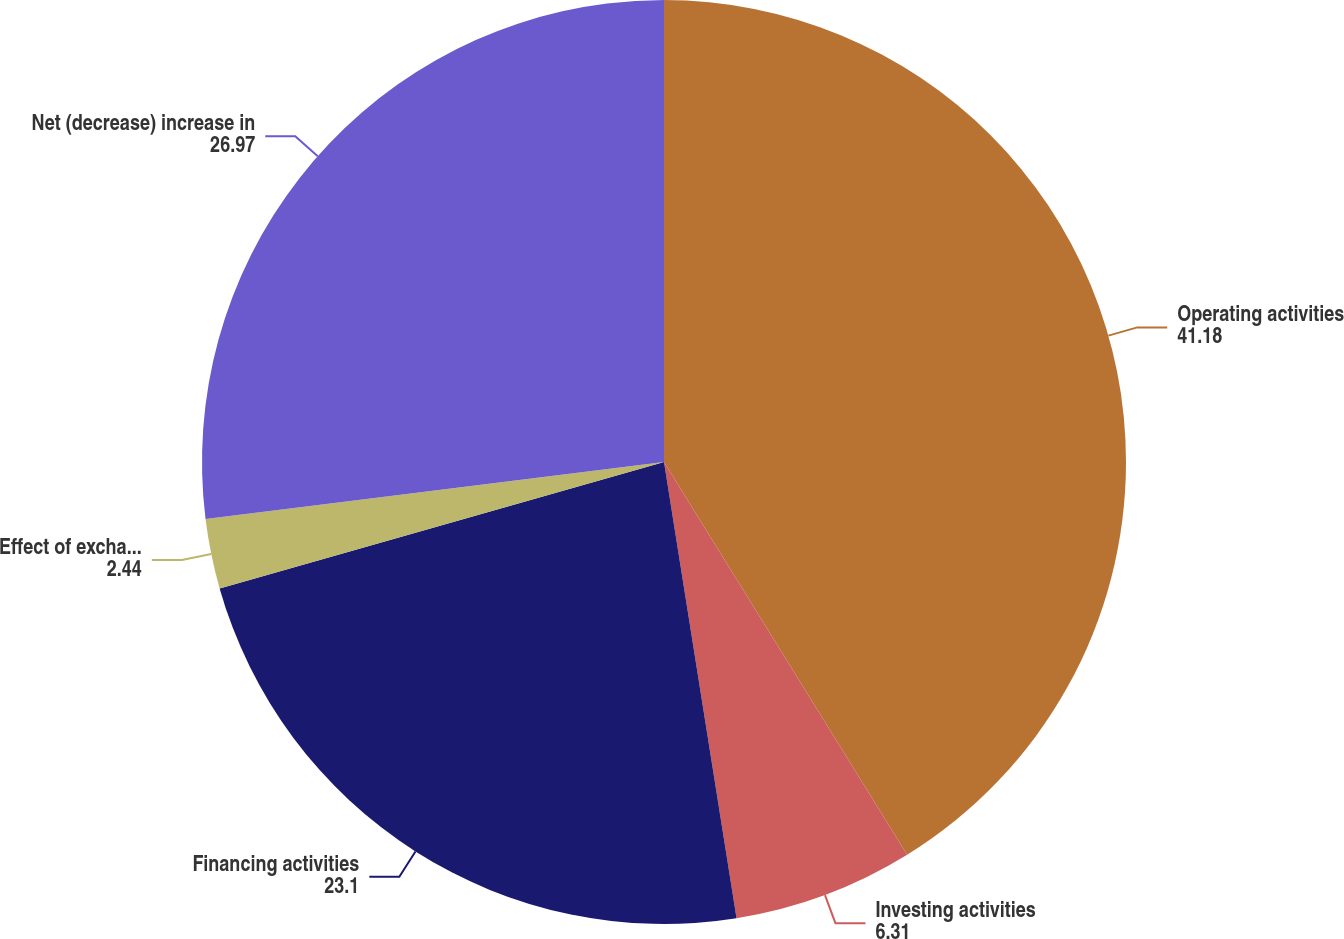<chart> <loc_0><loc_0><loc_500><loc_500><pie_chart><fcel>Operating activities<fcel>Investing activities<fcel>Financing activities<fcel>Effect of exchange rates on<fcel>Net (decrease) increase in<nl><fcel>41.18%<fcel>6.31%<fcel>23.1%<fcel>2.44%<fcel>26.97%<nl></chart> 